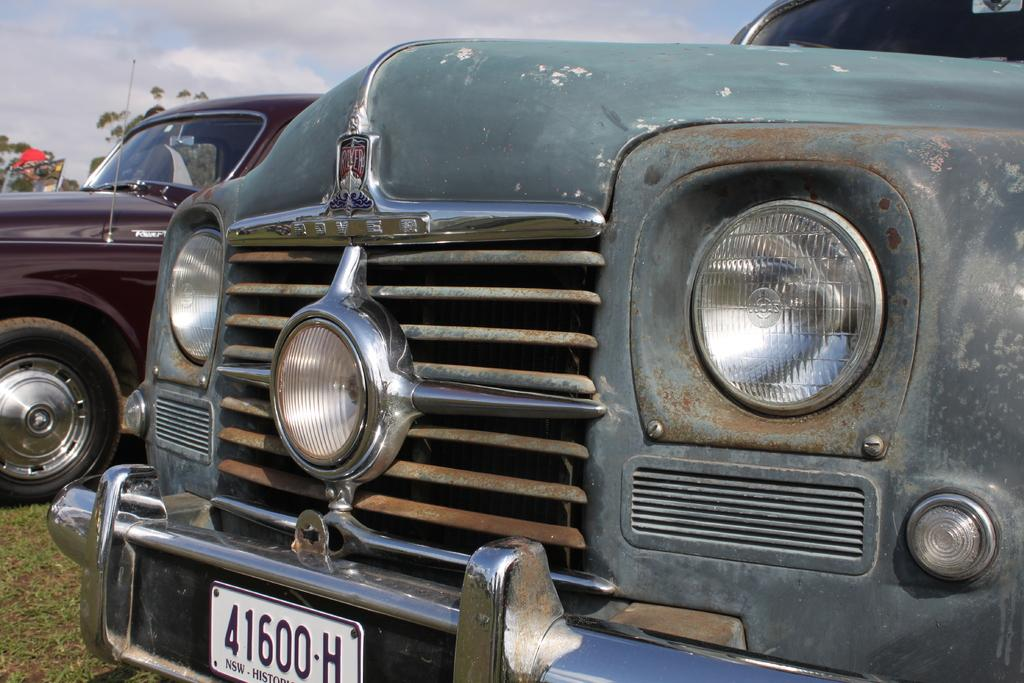What type of vehicles can be seen in the image? There are cars in the image. What can be seen in the background of the image? There are trees and the sky visible in the background of the image. What type of terrain is at the bottom of the image? There is grass at the bottom of the image. Where is the dock located in the image? There is no dock present in the image. Can you tell me how many oranges are on the trees in the image? There are no oranges visible in the image; only trees are present. 